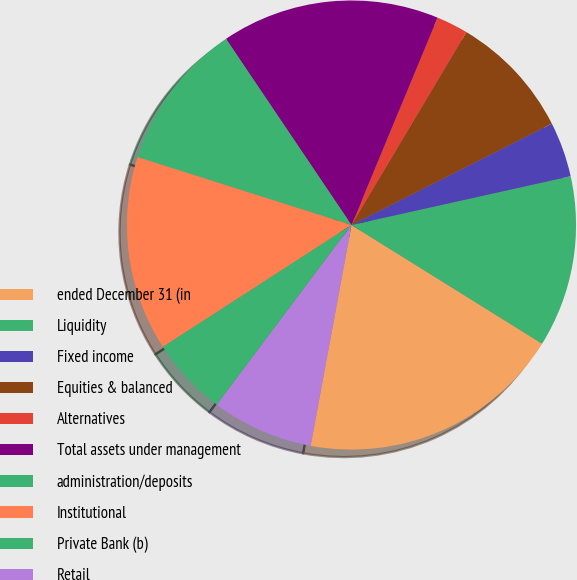<chart> <loc_0><loc_0><loc_500><loc_500><pie_chart><fcel>ended December 31 (in<fcel>Liquidity<fcel>Fixed income<fcel>Equities & balanced<fcel>Alternatives<fcel>Total assets under management<fcel>administration/deposits<fcel>Institutional<fcel>Private Bank (b)<fcel>Retail<nl><fcel>19.05%<fcel>12.35%<fcel>3.97%<fcel>8.99%<fcel>2.29%<fcel>15.7%<fcel>10.67%<fcel>14.02%<fcel>5.64%<fcel>7.32%<nl></chart> 